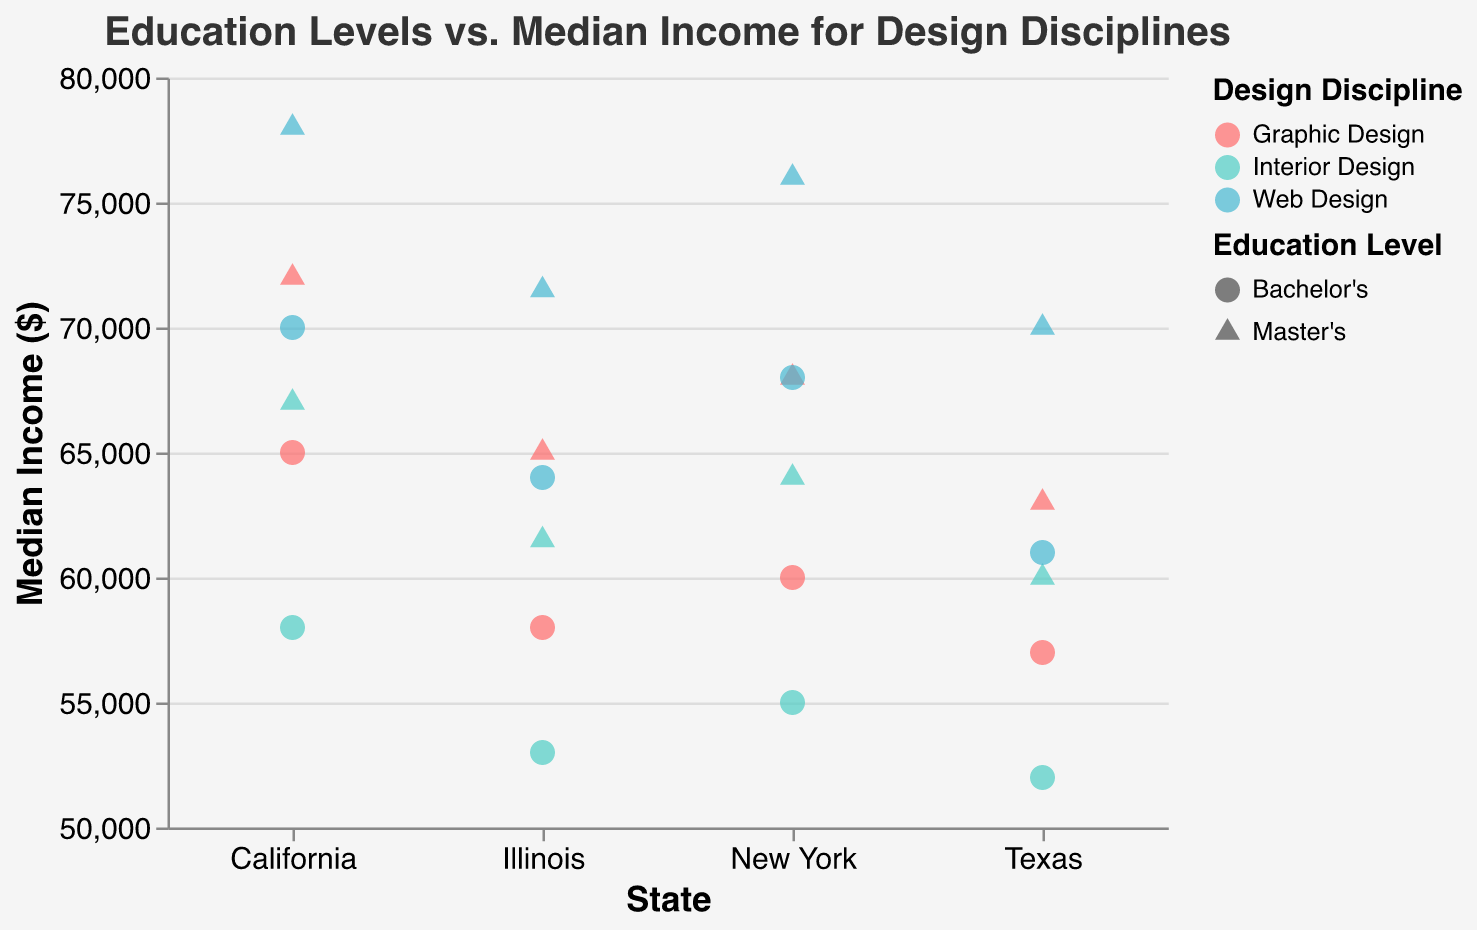What is the title of the scatter plot? The title of the scatter plot is displayed at the top of the figure. It reads "Education Levels vs. Median Income for Design Disciplines".
Answer: Education Levels vs. Median Income for Design Disciplines Which state shows the highest median income for Master's degree holders in Web Design? To find this, look at the decision plot and locate master's degree holders (triangles) in Web Design (color-coded). Check the y-axis values for all states and compare.
Answer: California How does the median income of Bachelor’s degree holders in Interior Design in New York compare to those in Texas? Locate the circles for Bachelor’s degree in Interior Design for New York and Texas on the chart. Compare the y-axis values of these circles. In New York, it is 55000, and in Texas, it is 52000.
Answer: Higher in New York What is the general trend between education level and median income in this figure? Observe the shapes that represent different education levels. Triangles (Master's) generally have higher y-axis values compared to circles (Bachelor's), indicating higher median income for higher education levels.
Answer: Higher education levels correspond to higher median income For which design discipline is the median income consistently higher across all states? Compare the median income values for each design discipline color-coded in the legend. Web Design values are consistently higher across states in both Bachelor's and Master's levels.
Answer: Web Design What is the average median income for Graphic Design Bachelor's degree holders across all states? Identify and sum the y-axis (Median Income) values for Graphic Design Bachelor's degree holders in all states (65000 in California, 60000 in New York, 57000 in Texas, 58000 in Illinois). Then divide by the number of data points. Avg = (65000 + 60000 + 57000 + 58000) / 4 = 60000
Answer: 60000 Which design discipline shows the largest income increase from Bachelor’s to Master’s degrees in Illinois? Locate the points for both education levels in each discipline in Illinois. Calculate the difference for each (Master's - Bachelor's): Graphic Design (65000 - 58000), Interior Design (61500 - 53000), Web Design (71500 - 64000). The highest difference is 7500, which is in Web Design.
Answer: Web Design Are there any states where the median income for a Bachelor’s degree in Interior Design is higher than a Master’s degree in Graphic Design? Calculate and compare the y-axis values for Bachelor's in Interior Design and Master's in Graphic Design for every state. In Texas, Bachelor's in Interior Design (52000) is lower, but in California (58000 compared to 72000), New York (55000 compared to 68000), and Illinois (53000 compared to 65000) it's always lower.
Answer: No Which state shows the smallest difference in median income between Bachelor’s and Master’s in Interior Design? Calculate the difference in median income for Interior Design Bachelor's and Master's degrees in each state. Compare these differences: California (67000 - 58000), New York (64000 - 55000), Texas (60000 - 52000), Illinois (61500 - 53000). The smallest difference is in Texas with 8000.
Answer: Texas List the color used for each design discipline in this figure. Refer to the legend that indicates the colors representing each discipline. Graphic Design is red, Interior Design is mint green, Web Design is cyan.
Answer: Graphic Design: red, Interior Design: mint green, Web Design: cyan 